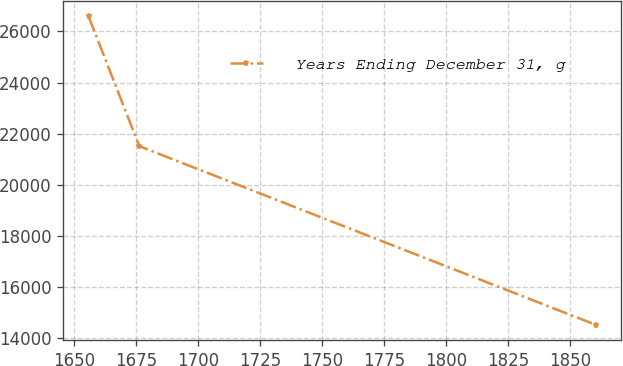<chart> <loc_0><loc_0><loc_500><loc_500><line_chart><ecel><fcel>Years Ending December 31, g<nl><fcel>1655.73<fcel>26591.1<nl><fcel>1676.18<fcel>21511.5<nl><fcel>1860.25<fcel>14517.8<nl></chart> 